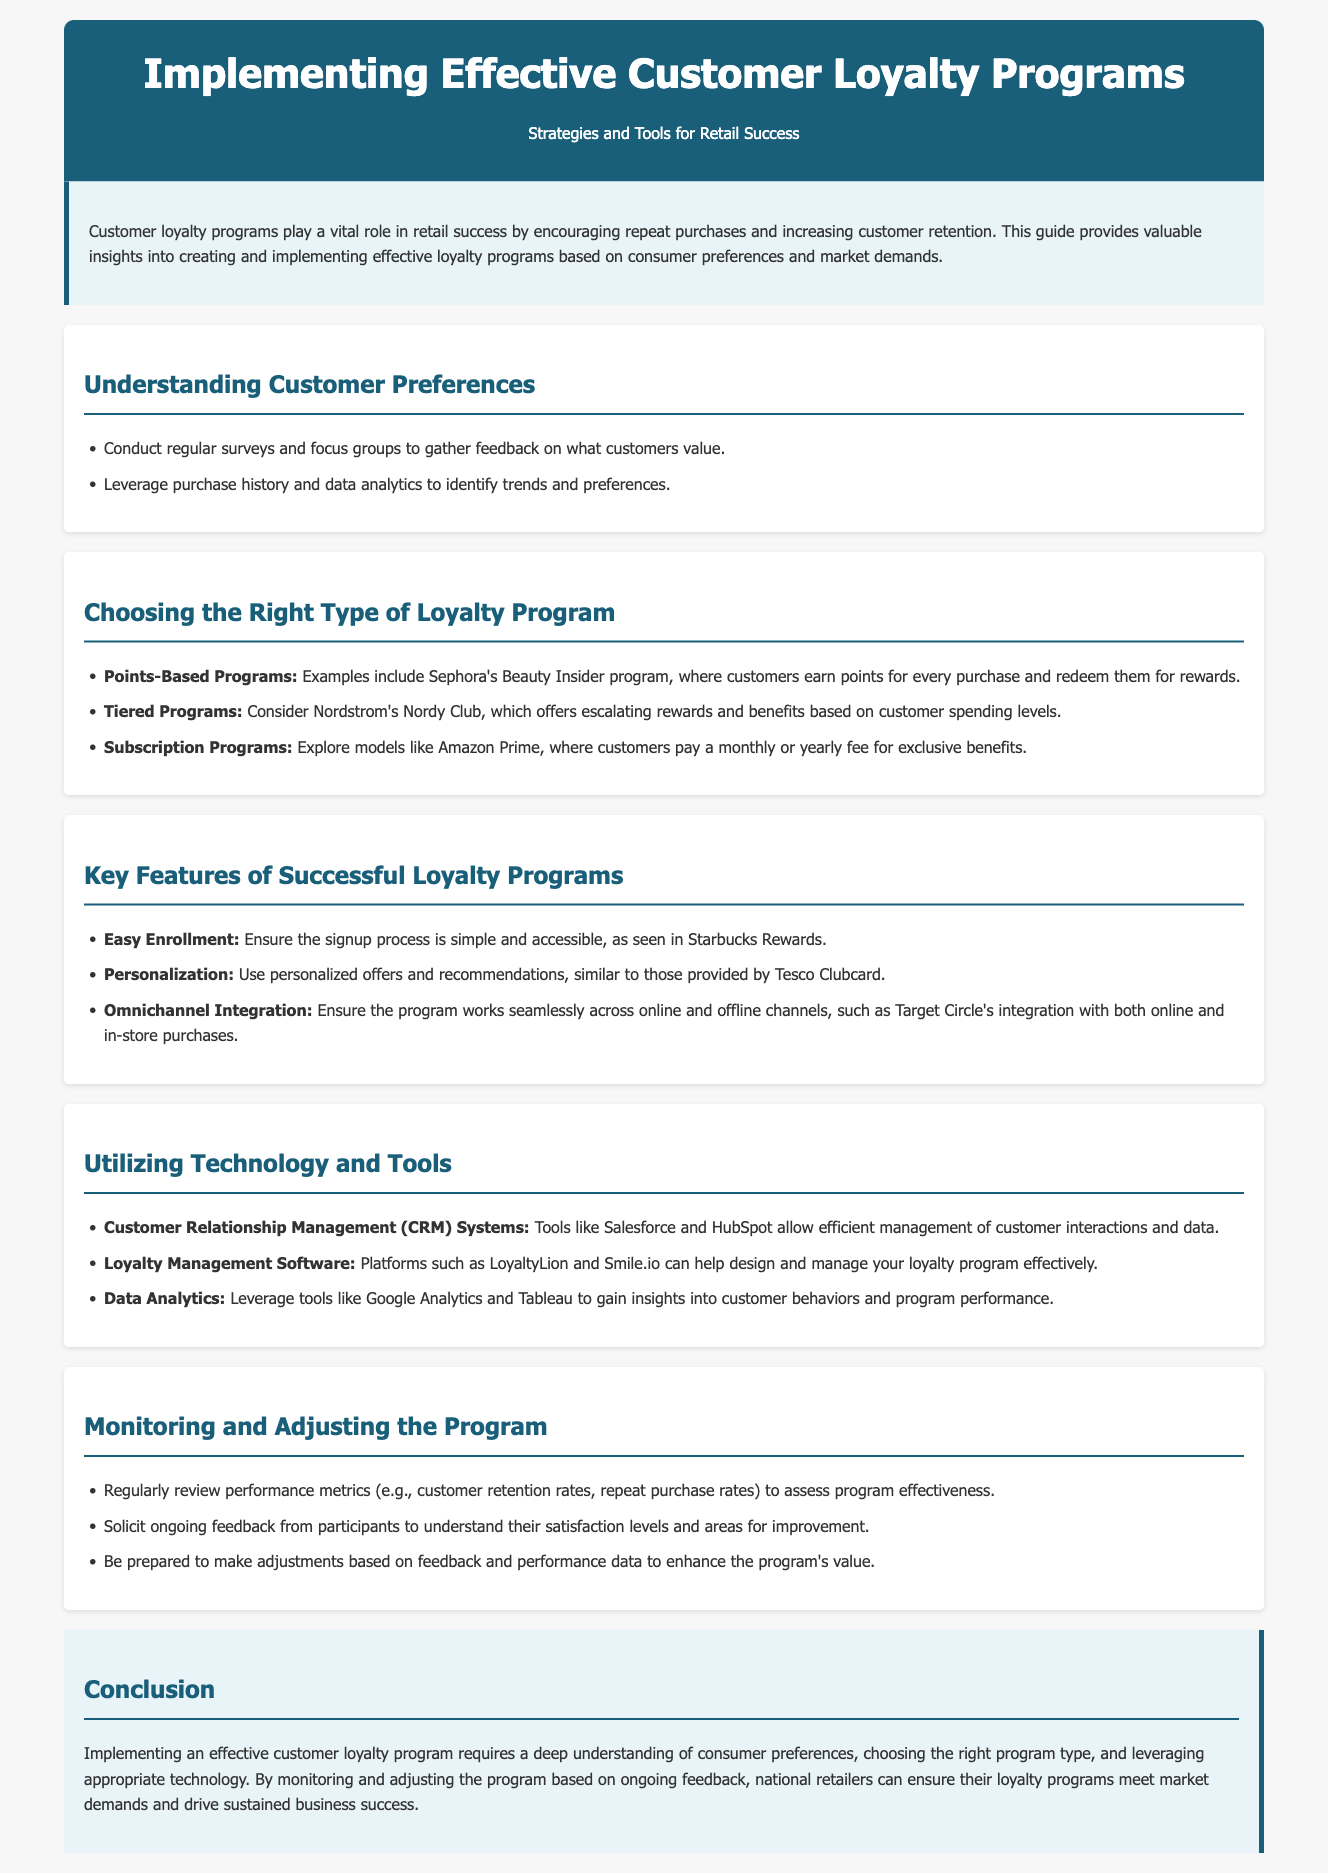what role do customer loyalty programs play in retail success? Customer loyalty programs encourage repeat purchases and increase customer retention.
Answer: repeat purchases and increase customer retention which survey methods are suggested for understanding customer preferences? The document mentions conducting regular surveys and focus groups to gather feedback on what customers value.
Answer: surveys and focus groups what type of loyalty program does Sephora use? Sephora uses a points-based program where customers earn points for every purchase and redeem them for rewards.
Answer: points-based program name one key feature of successful loyalty programs mentioned in the document. The document mentions easy enrollment as one of the key features of successful loyalty programs.
Answer: easy enrollment which CRM system is highlighted in the guide? The guide highlights Salesforce as a CRM system that allows efficient management of customer interactions and data.
Answer: Salesforce what factor should be monitored to assess program effectiveness? Performance metrics such as customer retention rates should be reviewed to assess the program's effectiveness.
Answer: customer retention rates how can technology support loyalty programs? Technology can support loyalty programs through tools like CRM systems, loyalty management software, and data analytics.
Answer: CRM systems, loyalty management software, and data analytics what type of program does Amazon Prime represent? Amazon Prime represents a subscription program where customers pay a fee for exclusive benefits.
Answer: subscription program which company offers a tiered loyalty program? Nordstrom offers a tiered loyalty program called Nordy Club.
Answer: Nordstrom 